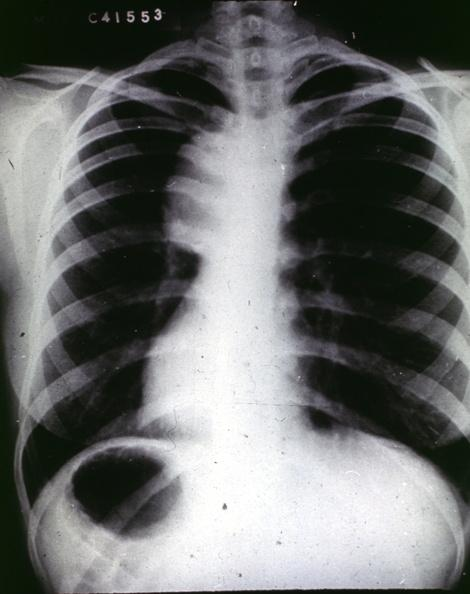s nipples present?
Answer the question using a single word or phrase. No 